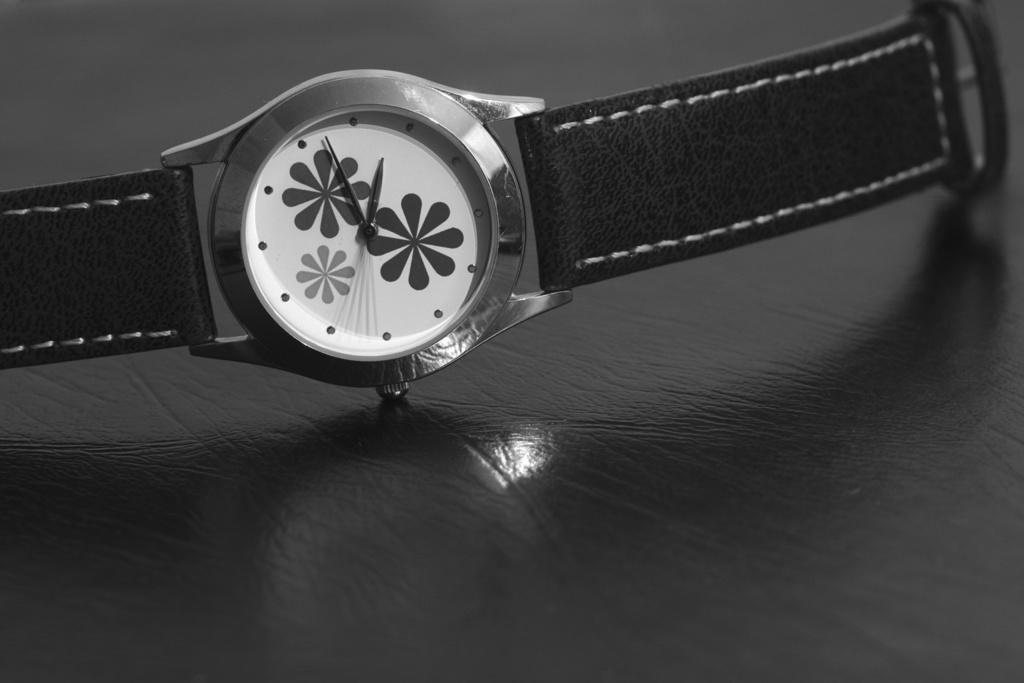What object can be seen in the image? There is a watch in the image. Where is the watch located? The watch is placed on a surface. How much regret is expressed by the watch in the image? There is no expression of regret by the watch in the image, as it is an inanimate object. 